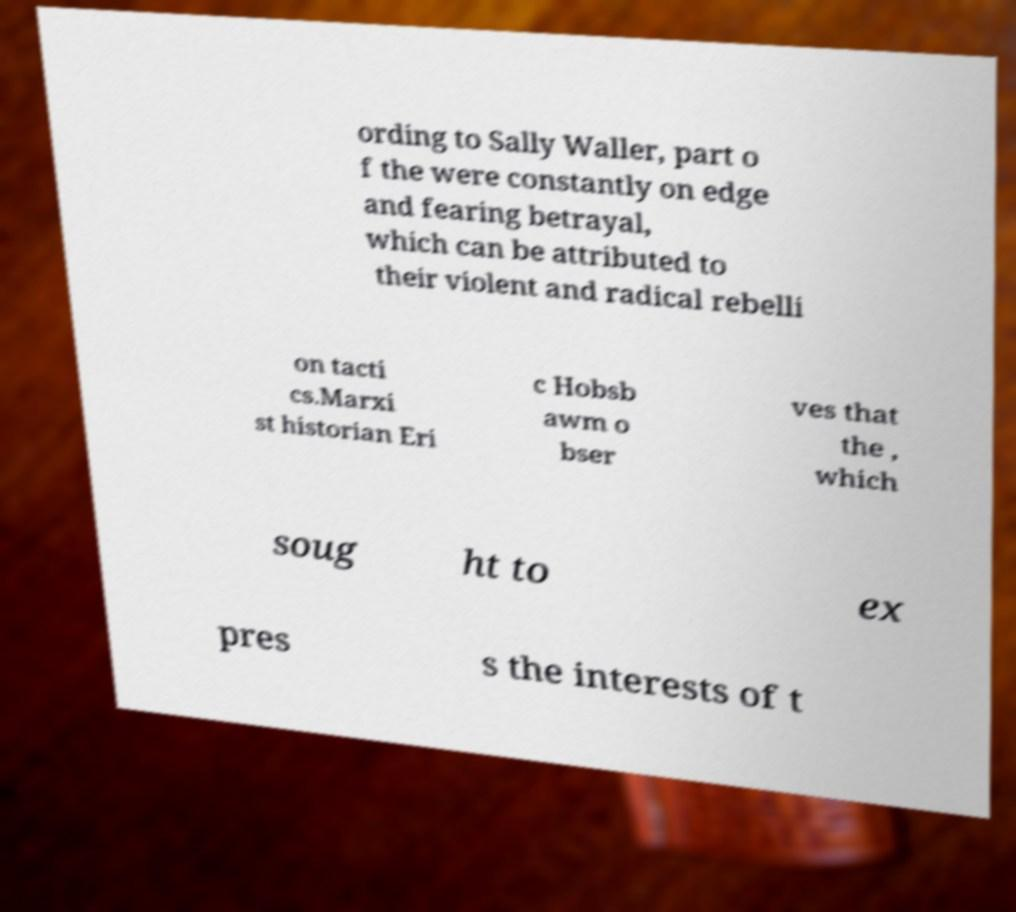There's text embedded in this image that I need extracted. Can you transcribe it verbatim? ording to Sally Waller, part o f the were constantly on edge and fearing betrayal, which can be attributed to their violent and radical rebelli on tacti cs.Marxi st historian Eri c Hobsb awm o bser ves that the , which soug ht to ex pres s the interests of t 